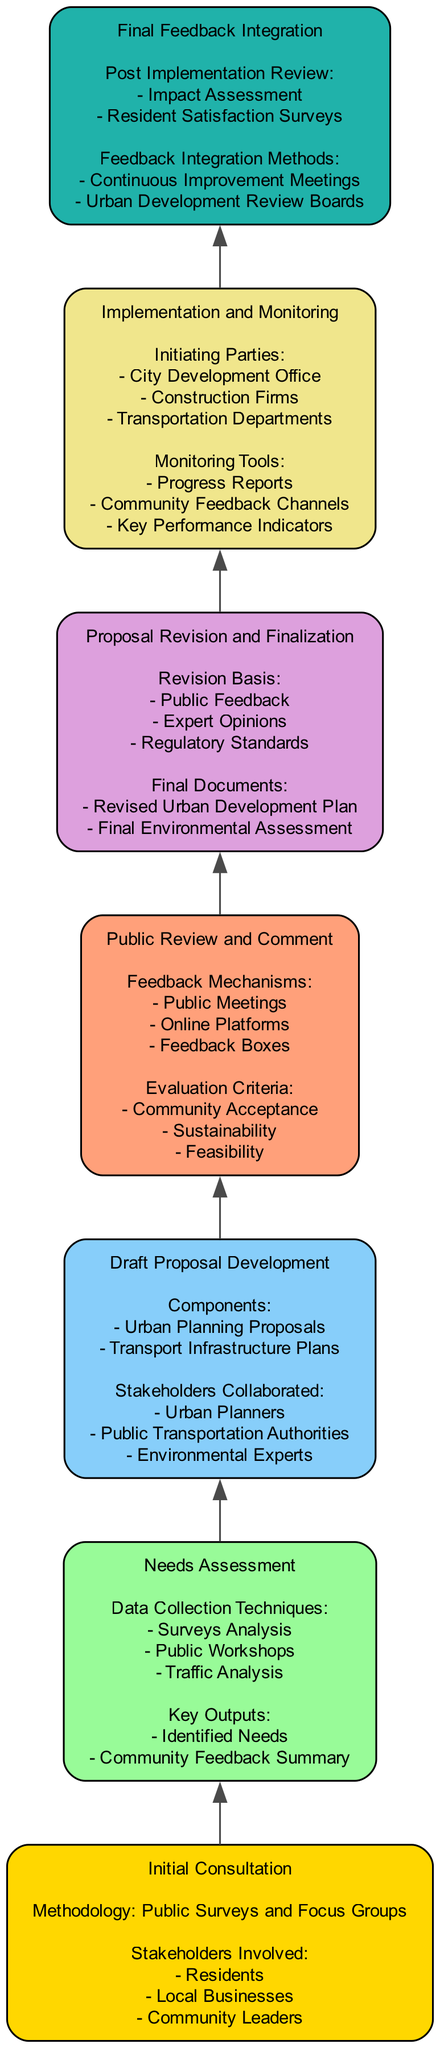What is the first stage in the public participation process? The first stage listed in the diagram is "Initial Consultation", which is positioned at the bottom of the flow chart indicating it is the starting point of the public participation process.
Answer: Initial Consultation How many key outputs are listed in the Needs Assessment stage? The Needs Assessment stage has two key outputs: "Identified Needs" and "Community Feedback Summary". Counting these gives us a total of two outputs.
Answer: 2 What mechanisms are used for feedback in the Public Review and Comment stage? The diagram states that the feedback mechanisms include "Public Meetings", "Online Platforms", and "Feedback Boxes". These methods are specifically mentioned in this stage, describing the ways in which stakeholders can provide input.
Answer: Public Meetings, Online Platforms, Feedback Boxes What are the initiating parties in the Implementation and Monitoring stage? The diagram shows that the initiating parties for this stage are "City Development Office", "Construction Firms", and "Transportation Departments". This information is directly obtained from the relevant stage in the flow chart.
Answer: City Development Office, Construction Firms, Transportation Departments What must be considered for Proposal Revision and Finalization? The Proposal Revision and Finalization stage focuses on three aspects for revisions: "Public Feedback", "Expert Opinions", and "Regulatory Standards", which are explicitly listed as necessary for this process step in the diagram.
Answer: Public Feedback, Expert Opinions, Regulatory Standards How does the flow progress from Draft Proposal Development to Public Review and Comment? The flow progresses sequentially from "Draft Proposal Development" to "Public Review and Comment" based on the vertical arrangement of stages in the flow chart. As seen in the diagram, it indicates the chronological order of activities in the public participation process.
Answer: By sequence in the flow What outputs are produced after the Final Feedback Integration? The diagram specifies that the outputs of this stage include "Impact Assessment" and "Resident Satisfaction Surveys", illustrating what is generated following the integration of final feedback.
Answer: Impact Assessment, Resident Satisfaction Surveys What color is used for the Draft Proposal Development stage? In the diagram, colors are assigned to different stages. The Draft Proposal Development stage is filled with a light blue color, which is specifically designated for this particular stage.
Answer: Light blue What type of feedback mechanism is emphasized in the Final Feedback Integration? The Final Feedback Integration stage emphasizes "Continuous Improvement Meetings" and "Urban Development Review Boards" as methods of integrating feedback, highlighting the focus on future enhancements based on stakeholder input.
Answer: Continuous Improvement Meetings, Urban Development Review Boards 